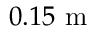<formula> <loc_0><loc_0><loc_500><loc_500>0 . 1 5 m</formula> 